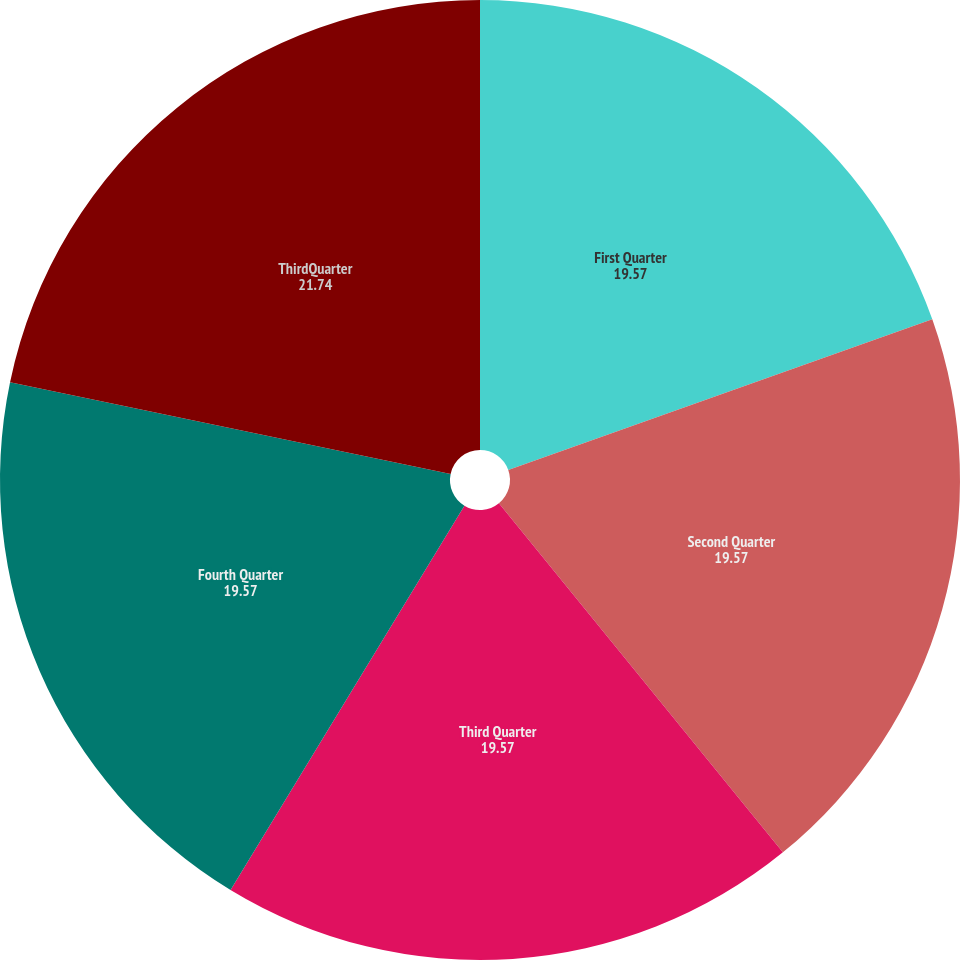Convert chart to OTSL. <chart><loc_0><loc_0><loc_500><loc_500><pie_chart><fcel>First Quarter<fcel>Second Quarter<fcel>Third Quarter<fcel>Fourth Quarter<fcel>ThirdQuarter<nl><fcel>19.57%<fcel>19.57%<fcel>19.57%<fcel>19.57%<fcel>21.74%<nl></chart> 